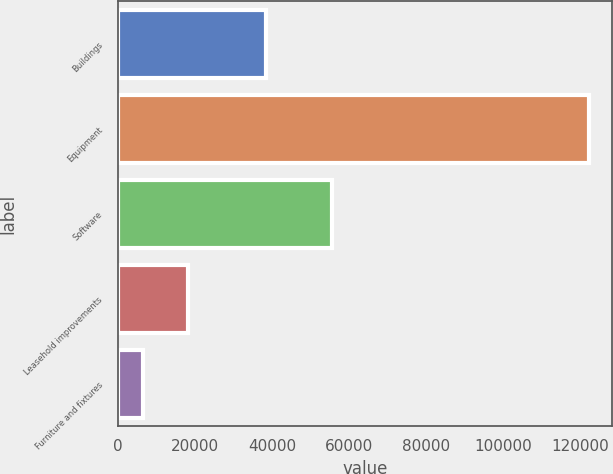<chart> <loc_0><loc_0><loc_500><loc_500><bar_chart><fcel>Buildings<fcel>Equipment<fcel>Software<fcel>Leasehold improvements<fcel>Furniture and fixtures<nl><fcel>38356<fcel>122200<fcel>55474<fcel>18092.5<fcel>6525<nl></chart> 